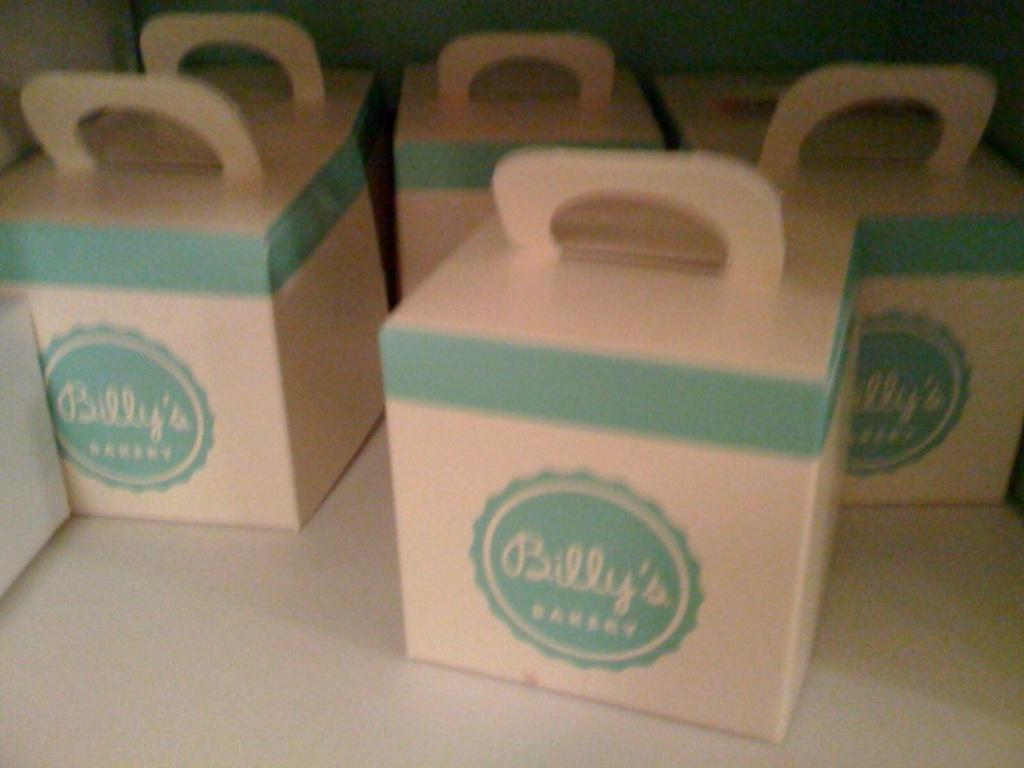<image>
Present a compact description of the photo's key features. boxes next to one another all labeled 'billy's bakery' 